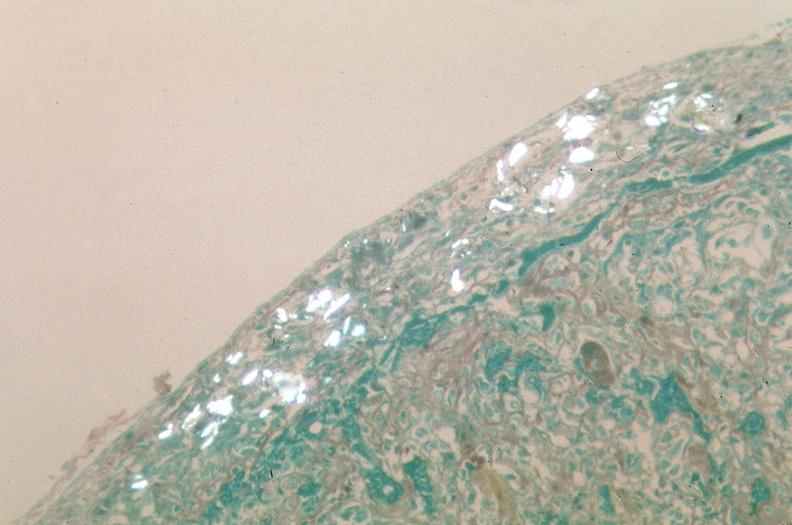what is present?
Answer the question using a single word or phrase. Respiratory 